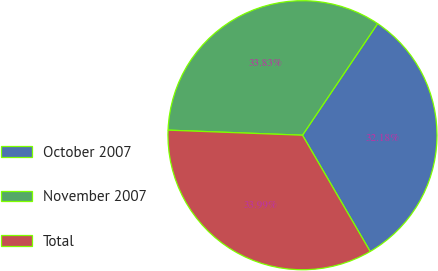Convert chart. <chart><loc_0><loc_0><loc_500><loc_500><pie_chart><fcel>October 2007<fcel>November 2007<fcel>Total<nl><fcel>32.18%<fcel>33.83%<fcel>33.99%<nl></chart> 